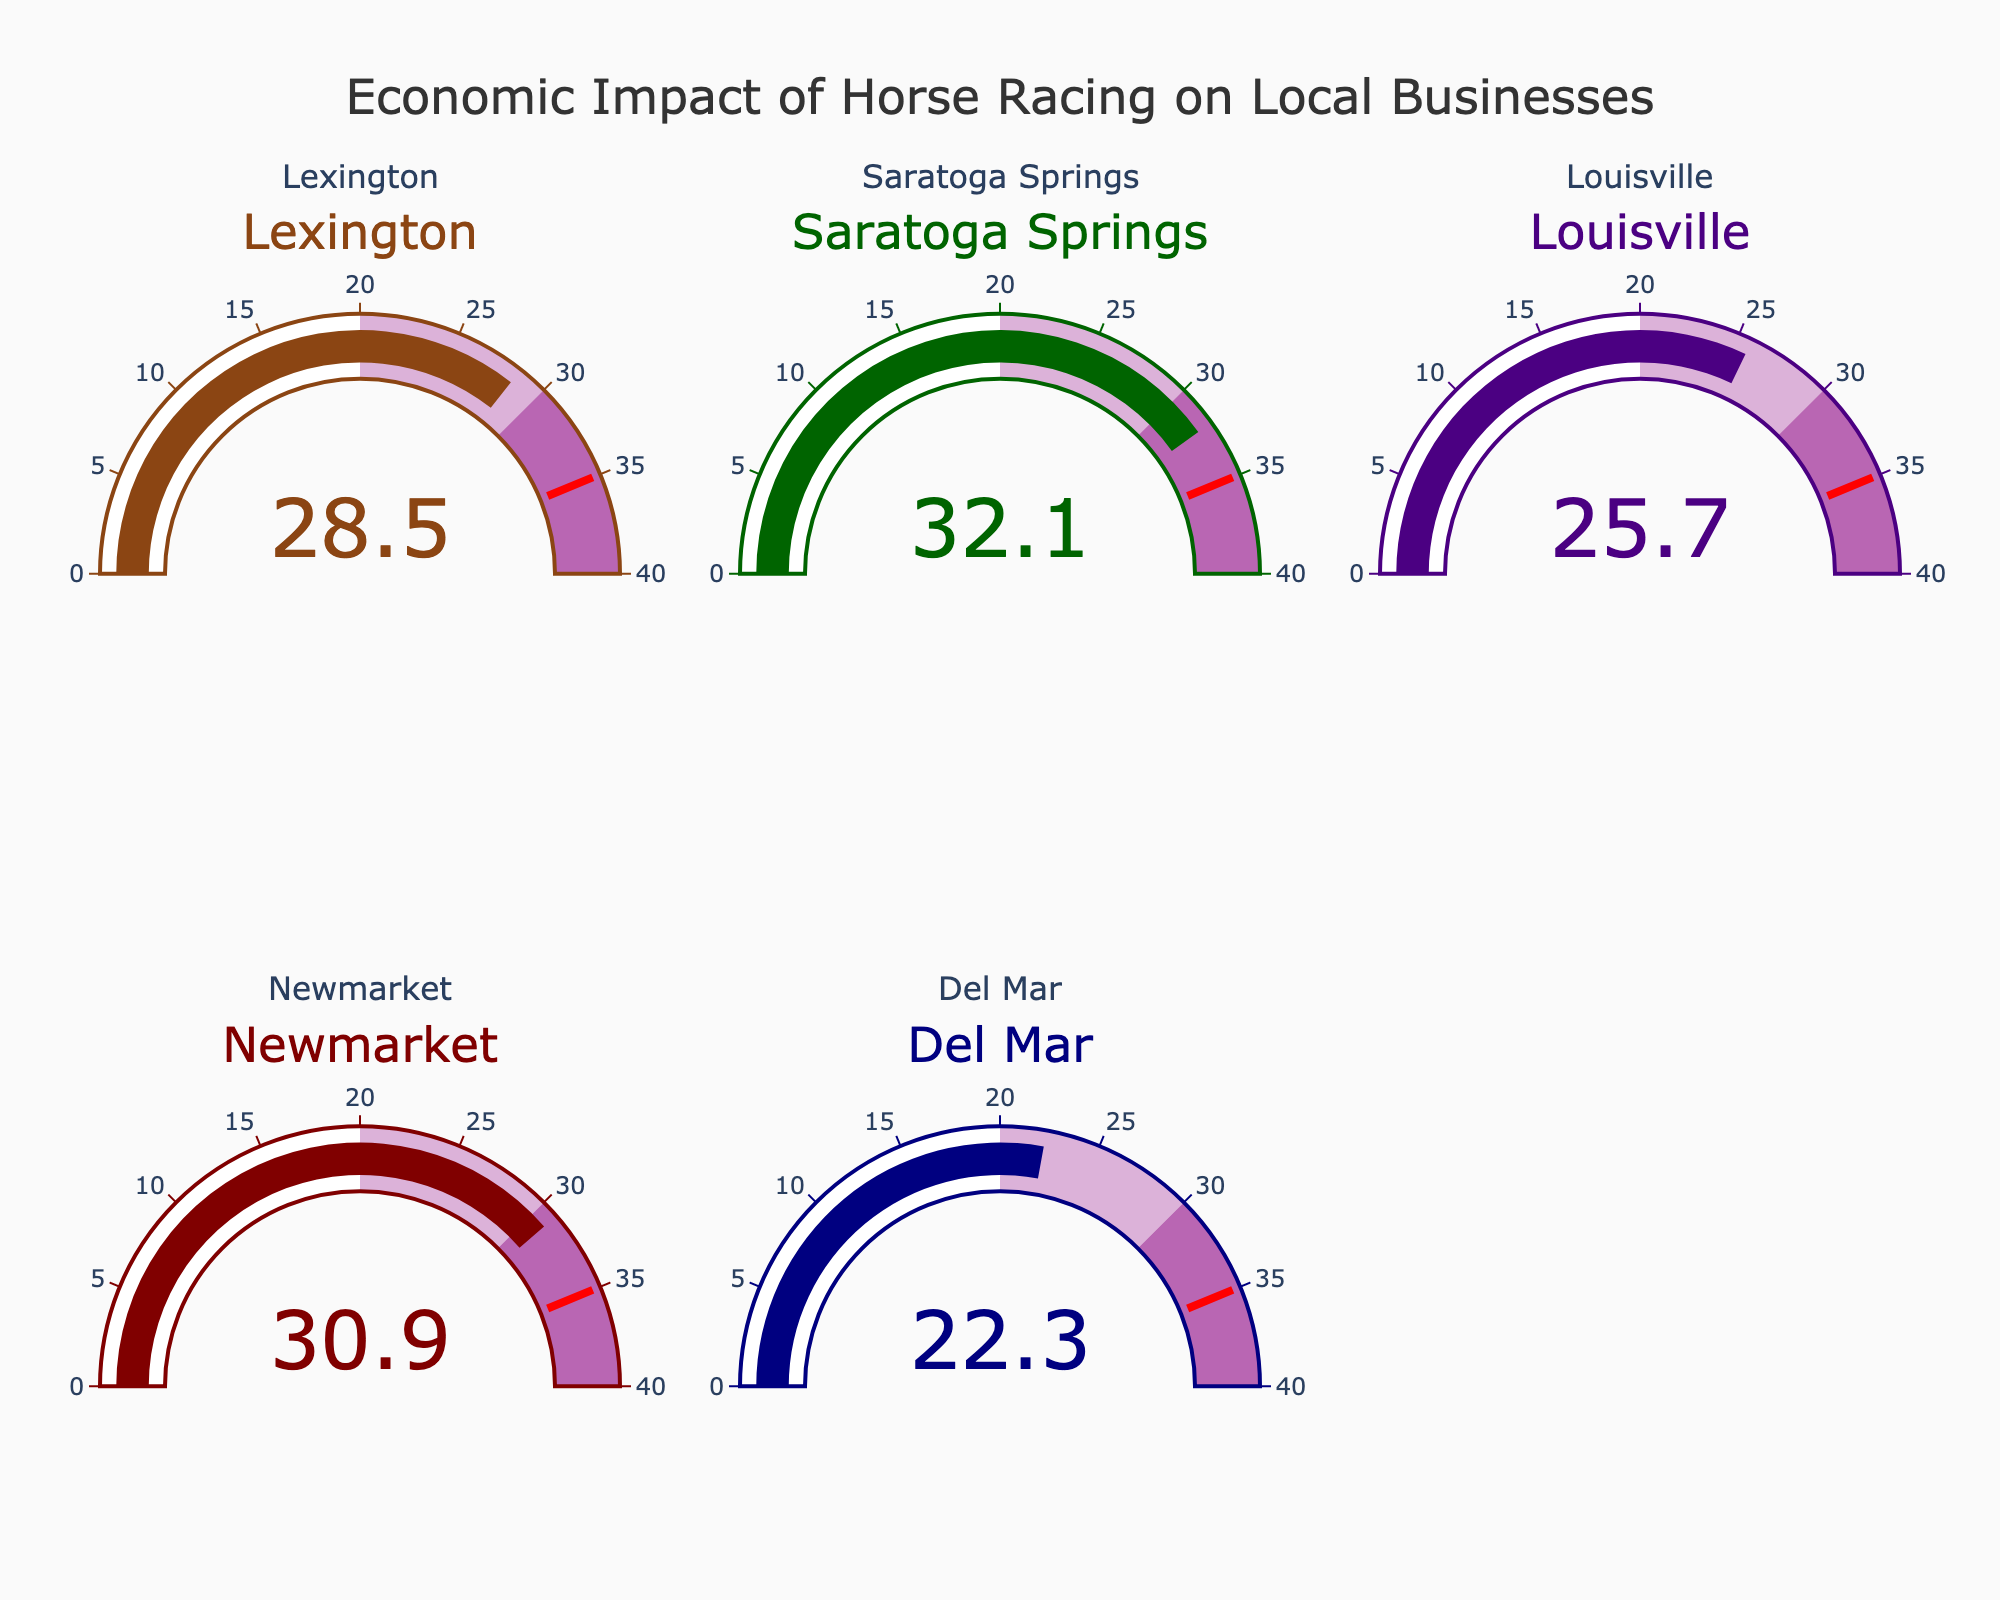what is the economic impact of horse racing on local businesses in Lexington? We look at the gauge chart labeled "Lexington" to find the economic impact value
Answer: 28.5% what is the economic impact of horse racing on local businesses in Del Mar? We look at the gauge chart labeled "Del Mar" to find the economic impact value
Answer: 22.3% which location has the highest economic impact of horse racing on local businesses? Among the five gauges, the highest value is 32.1% seen in the Saratoga Springs gauge
Answer: Saratoga Springs which location has the lowest economic impact of horse racing on local businesses? Among the five gauges, the lowest value is 22.3% seen in the Del Mar gauge
Answer: Del Mar what is the average economic impact of horse racing on local businesses across all listed locations? Sum the economic impact values for all locations (28.5 + 32.1 + 25.7 + 30.9 + 22.3) = 139.5, then divide by 5 (locations) to get the average
Answer: 27.9% how much higher is the economic impact of horse racing in Saratoga Springs compared to Louisville? Subtract Louisville's value from Saratoga Springs' value: 32.1 - 25.7 = 6.4%
Answer: 6.4% which two locations have the closest economic impacts of horse racing, and what is the difference? Newmarket (30.9) and Saratoga Springs (32.1) have the closest values. Subtract Newmarket's value from Saratoga Springs': 32.1 - 30.9 = 1.2%
Answer: Newmarket and Saratoga Springs, 1.2% is the economic impact of horse racing in Lexington above or below the average impact across all listed locations? The average impact is 27.9%. Since Lexington's impact is 28.5%, it's above the average
Answer: Above which locations have an economic impact of horse racing above 30%? Locations with values above 30% are Saratoga Springs and Newmarket
Answer: Saratoga Springs, Newmarket 